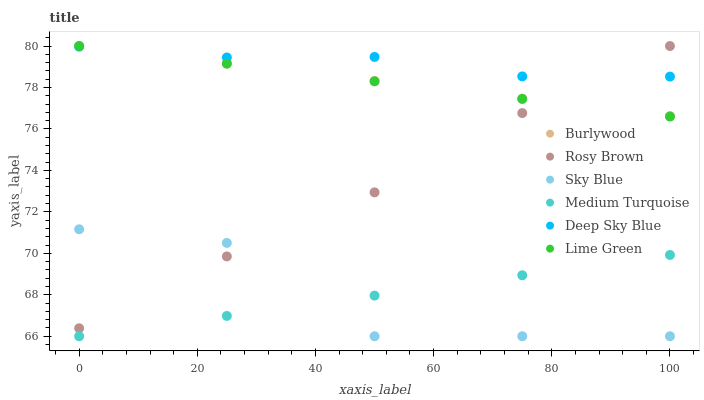Does Sky Blue have the minimum area under the curve?
Answer yes or no. Yes. Does Deep Sky Blue have the maximum area under the curve?
Answer yes or no. Yes. Does Burlywood have the minimum area under the curve?
Answer yes or no. No. Does Burlywood have the maximum area under the curve?
Answer yes or no. No. Is Medium Turquoise the smoothest?
Answer yes or no. Yes. Is Sky Blue the roughest?
Answer yes or no. Yes. Is Burlywood the smoothest?
Answer yes or no. No. Is Burlywood the roughest?
Answer yes or no. No. Does Medium Turquoise have the lowest value?
Answer yes or no. Yes. Does Burlywood have the lowest value?
Answer yes or no. No. Does Lime Green have the highest value?
Answer yes or no. Yes. Does Deep Sky Blue have the highest value?
Answer yes or no. No. Is Sky Blue less than Deep Sky Blue?
Answer yes or no. Yes. Is Deep Sky Blue greater than Medium Turquoise?
Answer yes or no. Yes. Does Deep Sky Blue intersect Lime Green?
Answer yes or no. Yes. Is Deep Sky Blue less than Lime Green?
Answer yes or no. No. Is Deep Sky Blue greater than Lime Green?
Answer yes or no. No. Does Sky Blue intersect Deep Sky Blue?
Answer yes or no. No. 